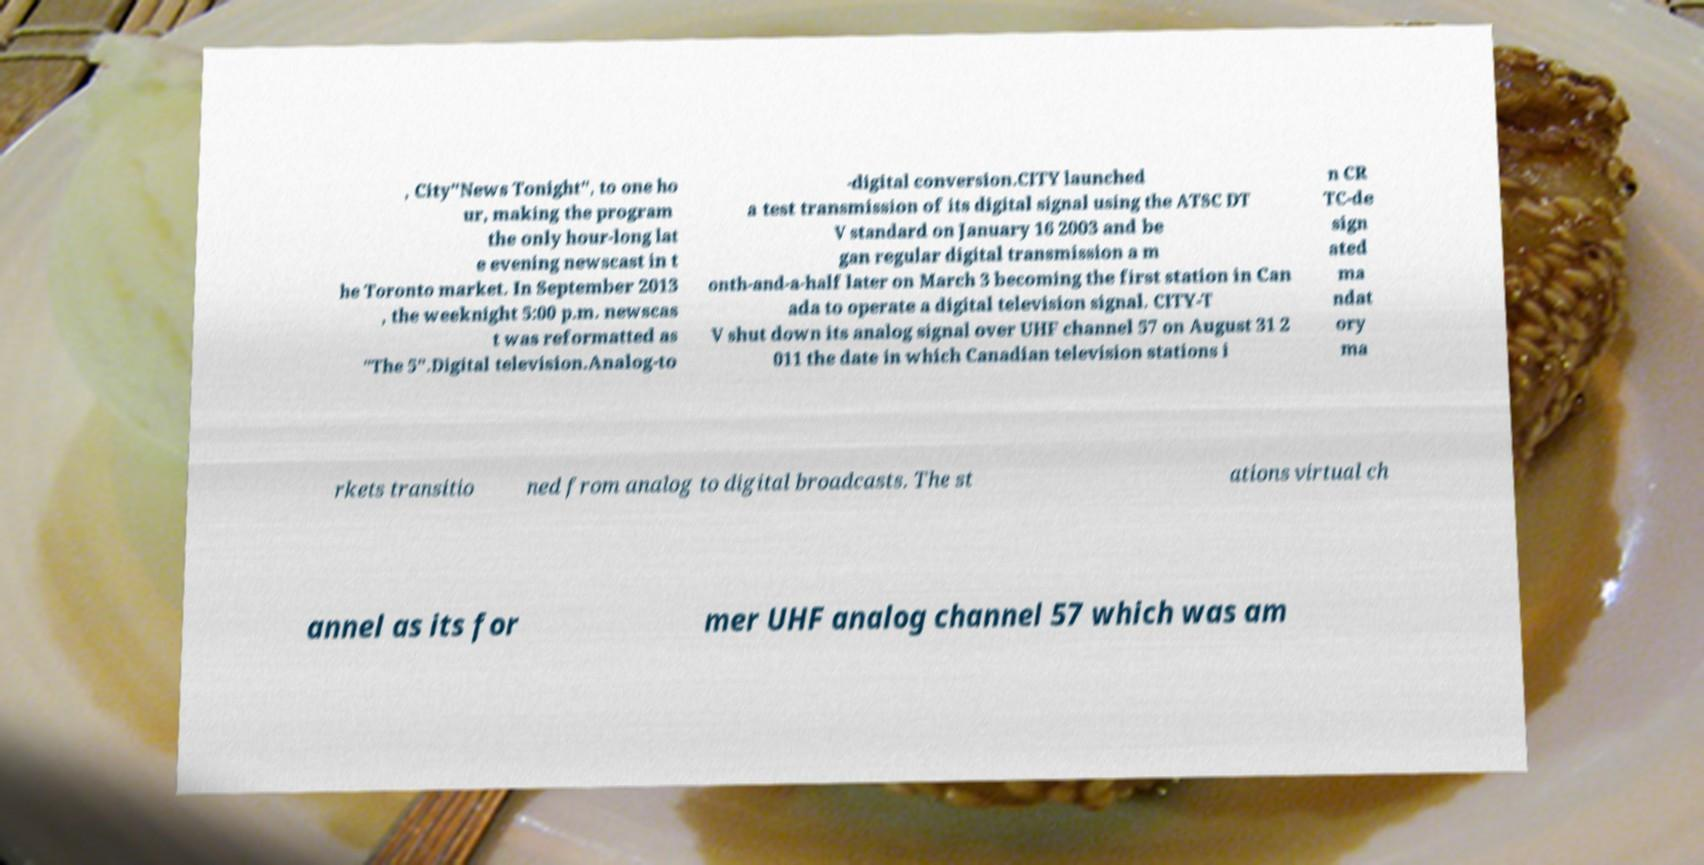What messages or text are displayed in this image? I need them in a readable, typed format. , City"News Tonight", to one ho ur, making the program the only hour-long lat e evening newscast in t he Toronto market. In September 2013 , the weeknight 5:00 p.m. newscas t was reformatted as "The 5".Digital television.Analog-to -digital conversion.CITY launched a test transmission of its digital signal using the ATSC DT V standard on January 16 2003 and be gan regular digital transmission a m onth-and-a-half later on March 3 becoming the first station in Can ada to operate a digital television signal. CITY-T V shut down its analog signal over UHF channel 57 on August 31 2 011 the date in which Canadian television stations i n CR TC-de sign ated ma ndat ory ma rkets transitio ned from analog to digital broadcasts. The st ations virtual ch annel as its for mer UHF analog channel 57 which was am 